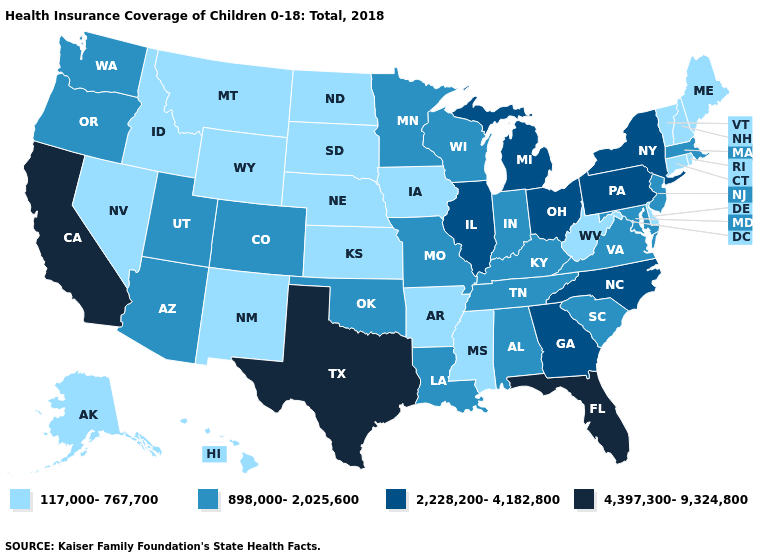What is the value of Arizona?
Answer briefly. 898,000-2,025,600. What is the value of Oregon?
Be succinct. 898,000-2,025,600. Among the states that border West Virginia , which have the lowest value?
Answer briefly. Kentucky, Maryland, Virginia. Is the legend a continuous bar?
Concise answer only. No. Among the states that border Kentucky , does Virginia have the highest value?
Answer briefly. No. Does the first symbol in the legend represent the smallest category?
Write a very short answer. Yes. Name the states that have a value in the range 2,228,200-4,182,800?
Concise answer only. Georgia, Illinois, Michigan, New York, North Carolina, Ohio, Pennsylvania. What is the lowest value in states that border Maryland?
Give a very brief answer. 117,000-767,700. Name the states that have a value in the range 898,000-2,025,600?
Give a very brief answer. Alabama, Arizona, Colorado, Indiana, Kentucky, Louisiana, Maryland, Massachusetts, Minnesota, Missouri, New Jersey, Oklahoma, Oregon, South Carolina, Tennessee, Utah, Virginia, Washington, Wisconsin. Which states have the lowest value in the West?
Keep it brief. Alaska, Hawaii, Idaho, Montana, Nevada, New Mexico, Wyoming. Among the states that border Utah , does Arizona have the lowest value?
Write a very short answer. No. Among the states that border Wyoming , does Montana have the highest value?
Be succinct. No. What is the value of Utah?
Be succinct. 898,000-2,025,600. What is the value of Missouri?
Answer briefly. 898,000-2,025,600. How many symbols are there in the legend?
Write a very short answer. 4. 